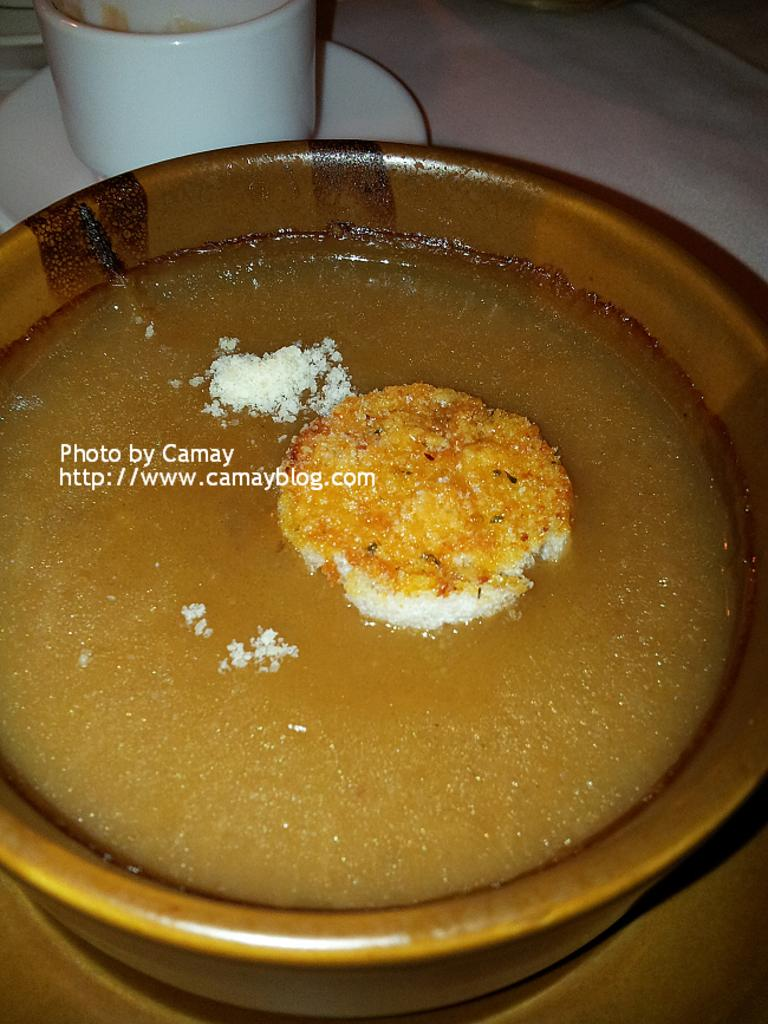What piece of furniture is present in the image? There is a table in the image. What is on the table? There is a bowl with a food item on the table. What can be seen in the background of the image? In the background, there is a cup and a plate. What type of pet is sitting on the table in the image? There is no pet present on the table in the image. Is the queen of England present in the image? There is no indication of the queen of England being present in the image. 